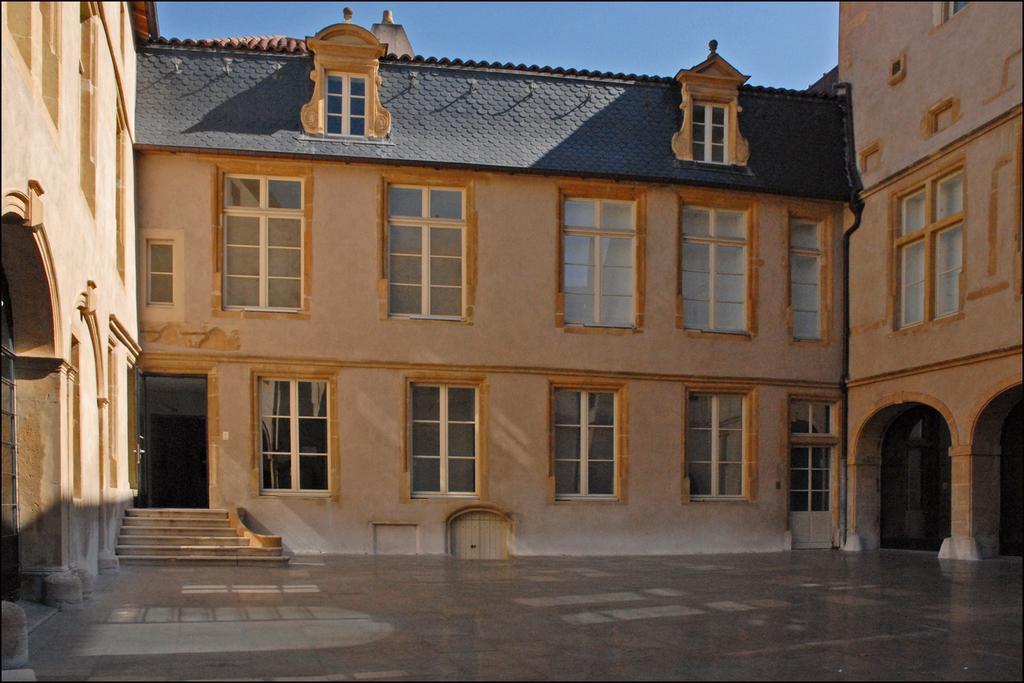Please provide a concise description of this image. In this image there is the sky towards the top of the image, there is a building, there are windows, there is a door, there are staircase, at the bottom of the image there is the ground, towards the right of the image there is a wall, towards the left of the image there is a wall. 